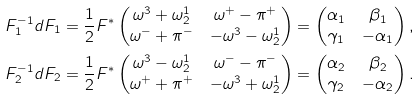<formula> <loc_0><loc_0><loc_500><loc_500>F _ { 1 } ^ { - 1 } d F _ { 1 } & = \frac { 1 } { 2 } F ^ { * } \begin{pmatrix} \omega ^ { 3 } + \omega _ { 2 } ^ { 1 } & \omega ^ { + } - \pi ^ { + } \\ \omega ^ { - } + \pi ^ { - } & - \omega ^ { 3 } - \omega _ { 2 } ^ { 1 } \end{pmatrix} = \begin{pmatrix} \alpha _ { 1 } & \beta _ { 1 } \\ \gamma _ { 1 } & - \alpha _ { 1 } \end{pmatrix} , \\ F _ { 2 } ^ { - 1 } d F _ { 2 } & = \frac { 1 } { 2 } F ^ { * } \begin{pmatrix} \omega ^ { 3 } - \omega _ { 2 } ^ { 1 } & \omega ^ { - } - \pi ^ { - } \\ \omega ^ { + } + \pi ^ { + } & - \omega ^ { 3 } + \omega _ { 2 } ^ { 1 } \end{pmatrix} = \begin{pmatrix} \alpha _ { 2 } & \beta _ { 2 } \\ \gamma _ { 2 } & - \alpha _ { 2 } \end{pmatrix} .</formula> 